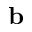Convert formula to latex. <formula><loc_0><loc_0><loc_500><loc_500>{ b }</formula> 